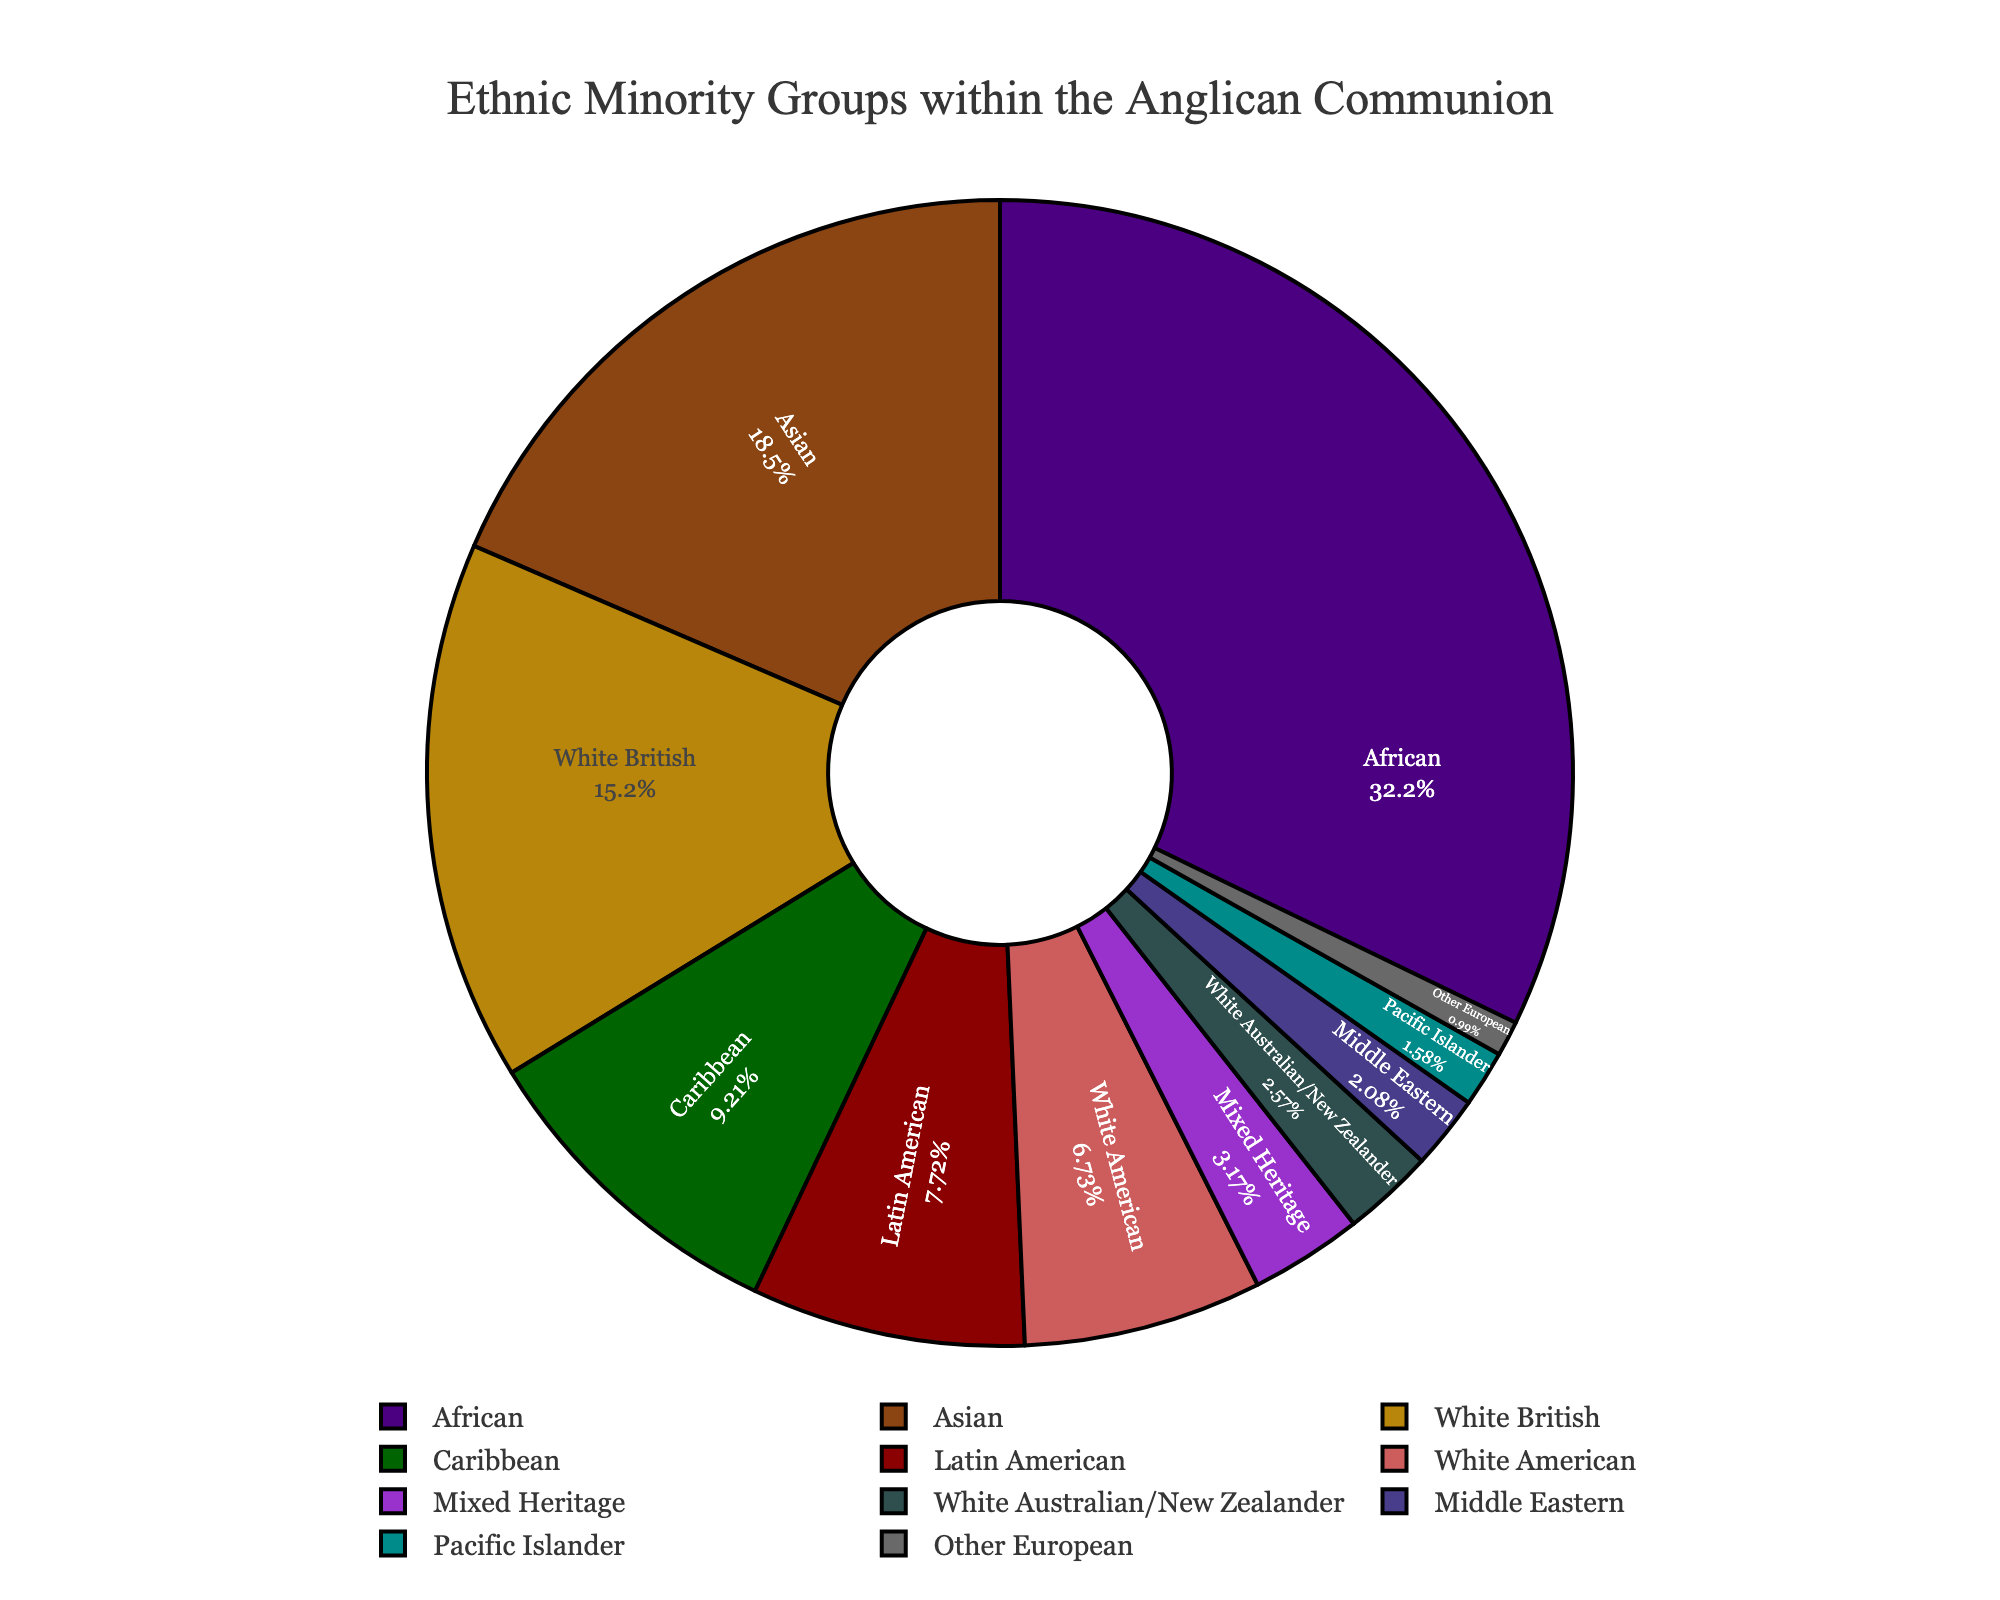What is the largest ethnic minority group within the Anglican Communion? The figure shows that the African group has the largest percentage at 32.5%.
Answer: African What is the combined percentage of the Caribbean and Latin American ethnic groups? The figure shows the Caribbean group at 9.3% and the Latin American group at 7.8%. Adding these together, 9.3% + 7.8% = 17.1%.
Answer: 17.1% Which ethnic group has a higher proportion: Mixed Heritage or Pacific Islander? The figure indicates that Mixed Heritage has a proportion of 3.2% while Pacific Islander has a proportion of 1.6%. Since 3.2% > 1.6%, Mixed Heritage has a higher proportion.
Answer: Mixed Heritage What is the difference in percentage between the Asian and White American groups? The figure shows that the Asian group has 18.7% and the White American group has 6.8%. The difference is calculated as 18.7% - 6.8% = 11.9%.
Answer: 11.9% Which ethnic group has the smallest percentage within the Anglican Communion? The figure shows that the Other European group has the smallest percentage at 1.0%.
Answer: Other European What is the combined percentage of all White ethnic groups (White British, White American, and White Australian/New Zealander)? The figure shows that White British is 15.4%, White American is 6.8%, and White Australian/New Zealander is 2.6%. Adding these together, 15.4% + 6.8% + 2.6% = 24.8%.
Answer: 24.8% How does the percentage of Middle Eastern ethnic groups compare to that of the Caribbean ethnic groups? The figure shows that the Middle Eastern group has 2.1% and the Caribbean group has 9.3%. Since 2.1% < 9.3%, the Middle Eastern group has a smaller percentage compared to the Caribbean group.
Answer: Middle Eastern has a smaller percentage What is the average percentage of the African, Asian, and Caribbean ethnic groups? The figure shows that African has 32.5%, Asian has 18.7%, and Caribbean has 9.3%. The average is calculated by (32.5% + 18.7% + 9.3%) / 3 = 20.17%.
Answer: 20.17% What color represents the Latin American ethnic group in the chart? In the chart, the Latin American group is represented by a brownish color towards the bottom of the legend.
Answer: Brown If you sum up the percentages of the ethnic groups with less than 5%, what would be the total? The groups with less than 5% are Middle Eastern (2.1%), Pacific Islander (1.6%), Mixed Heritage (3.2%), and Other European (1.0%). Adding these together, 2.1% + 1.6% + 3.2% + 1.0% = 7.9%.
Answer: 7.9% 